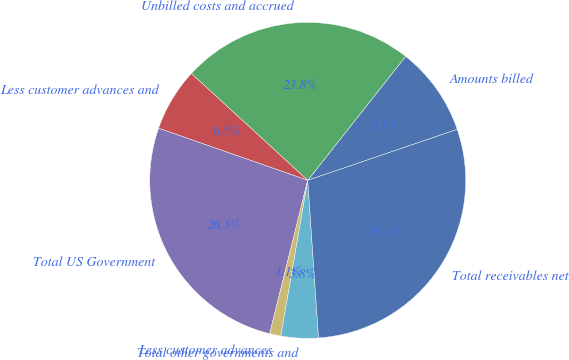<chart> <loc_0><loc_0><loc_500><loc_500><pie_chart><fcel>Amounts billed<fcel>Unbilled costs and accrued<fcel>Less customer advances and<fcel>Total US Government<fcel>Less customer advances<fcel>Total other governments and<fcel>Total receivables net<nl><fcel>9.13%<fcel>23.82%<fcel>6.47%<fcel>26.48%<fcel>1.15%<fcel>3.81%<fcel>29.14%<nl></chart> 